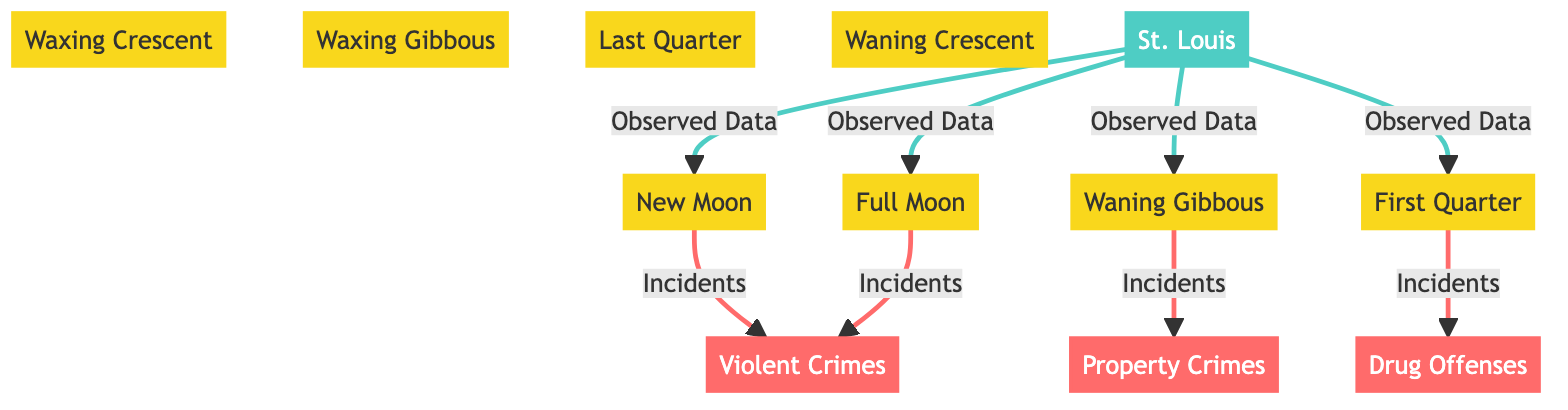What are the four moon phases that have observed data in St. Louis? The diagram shows four moon phases with observed data: New Moon, Full Moon, Waning Gibbous, and First Quarter.
Answer: New Moon, Full Moon, Waning Gibbous, First Quarter Which type of crime is linked to the New Moon? From the diagram, the New Moon node connects to Violent Crimes, indicating that Violent Crimes are linked to the New Moon.
Answer: Violent Crimes How many types of crimes are represented in the diagram? The diagram shows three types of crimes: Violent Crimes, Property Crimes, and Drug Offenses. Therefore, there are three types.
Answer: 3 What phase of the moon is associated with the highest number of crime incidents indicated in the diagram? The diagram reveals that Violent Crimes are associated with the Full Moon, which indicates a significant rise in incidents.
Answer: Full Moon Which type of crime is observed during the Waning Gibbous phase? The diagram shows that Property Crimes are the incident type linked with the Waning Gibbous phase.
Answer: Property Crimes Which moon phase has no direct connection to any crime type? Observing the diagram, the Waxing Crescent and Last Quarter phases do not have direct connections to any crime types listed.
Answer: Waxing Crescent, Last Quarter What crime types are associated with the First Quarter phase? According to the diagram, the First Quarter phase has a link to Drug Offenses as its associated crime type.
Answer: Drug Offenses Are there more types of crimes linked to the moon phases than there are moon phases themselves? The diagram shows three types of crimes connected to four moon phases, confirming that the number of crime types is less than the number of moon phases.
Answer: No Which moon phase is depicted between the New Moon and Full Moon in the diagram? The Waxing Crescent phase is positioned between the New Moon and Full Moon nodes in the diagram.
Answer: Waxing Crescent 